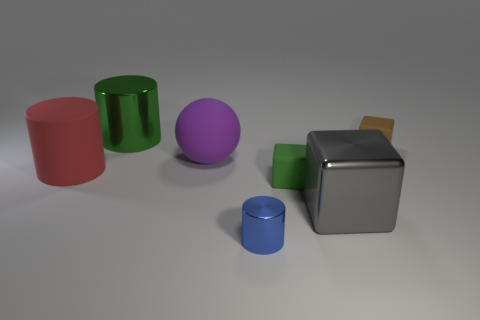Add 1 metal cylinders. How many objects exist? 8 Subtract all cubes. How many objects are left? 4 Add 5 red matte cylinders. How many red matte cylinders are left? 6 Add 6 large rubber spheres. How many large rubber spheres exist? 7 Subtract 0 cyan cylinders. How many objects are left? 7 Subtract all red matte cylinders. Subtract all tiny green things. How many objects are left? 5 